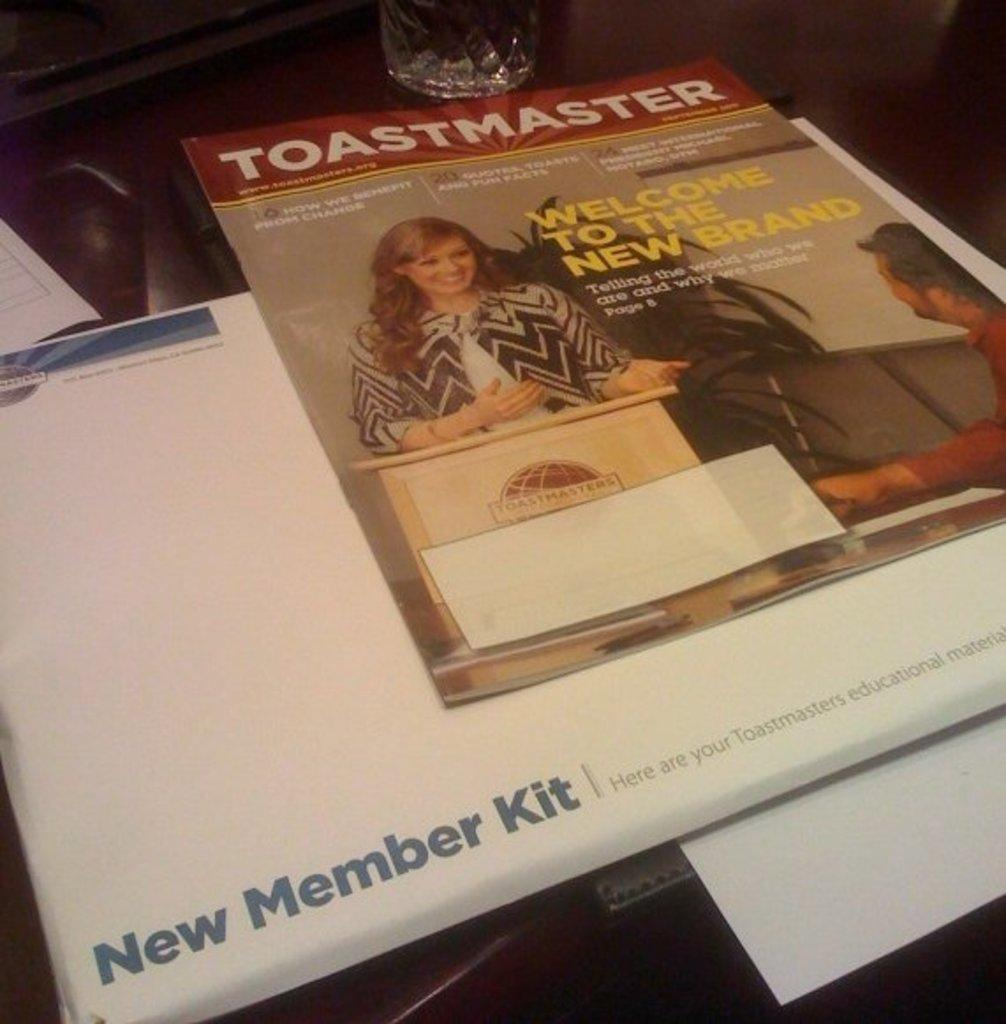What is depicted on the pamphlet in the image? The pamphlet contains a picture of a woman. What object is placed at the top of the pamphlet? There is a glass at the top of the pamphlet. What type of orange is being used to plough the field in the image? There is no orange or ploughing activity present in the image. 